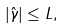Convert formula to latex. <formula><loc_0><loc_0><loc_500><loc_500>| \hat { \gamma } | \leq L ,</formula> 